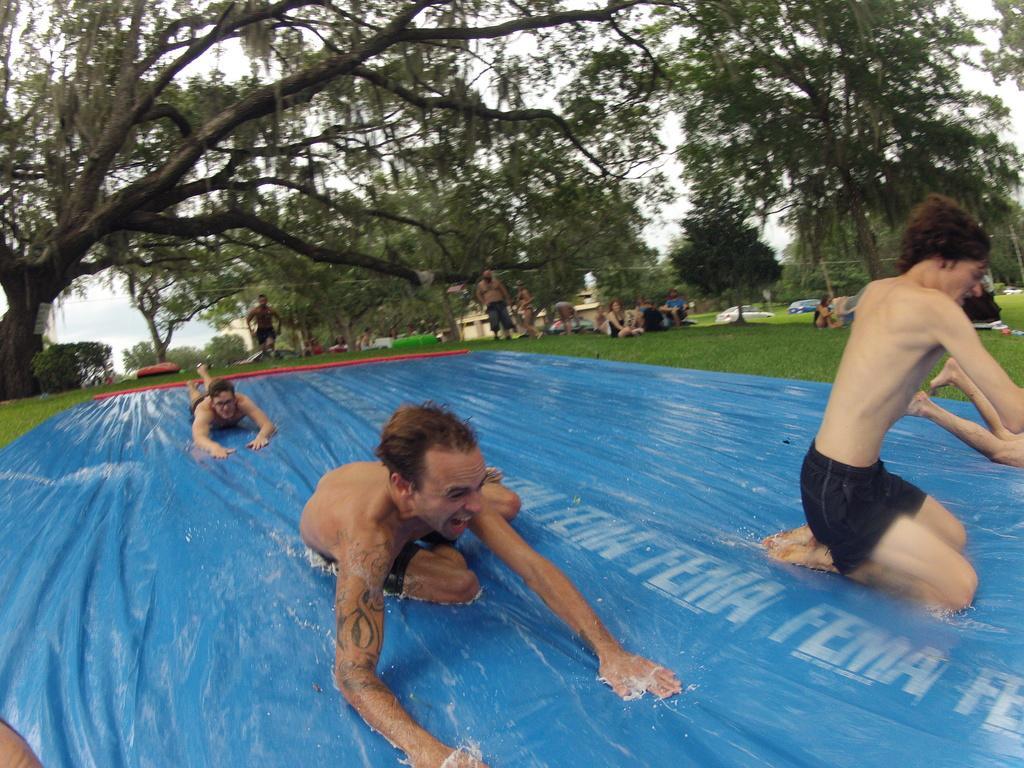Can you describe this image briefly? In this image we can see many trees. There is a grassy land in the image. There are few people sitting on the ground and few people standing on the ground. There are few vehicles at the right side of the image. There are few buildings in the image. We can see few people sliding on an object. There is some water on the blue colored object. 